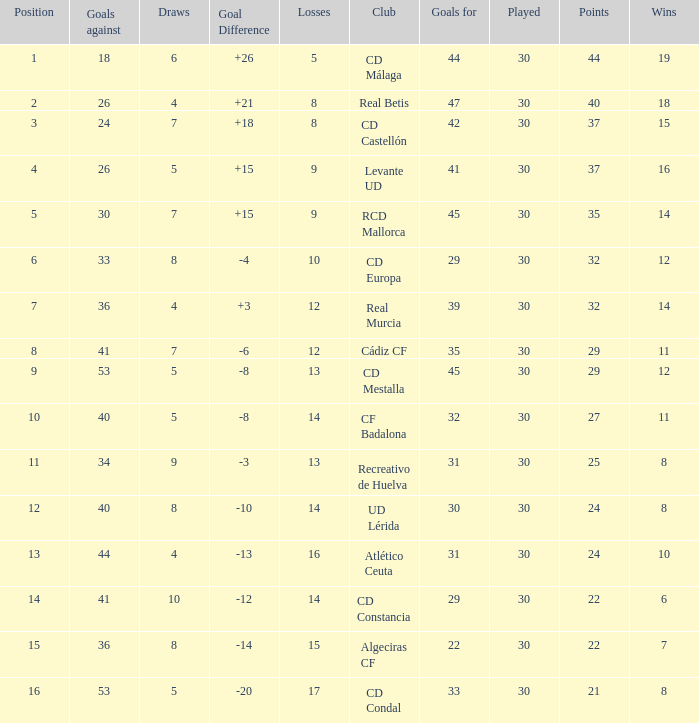What is the losses when the goal difference is larger than 26? None. 